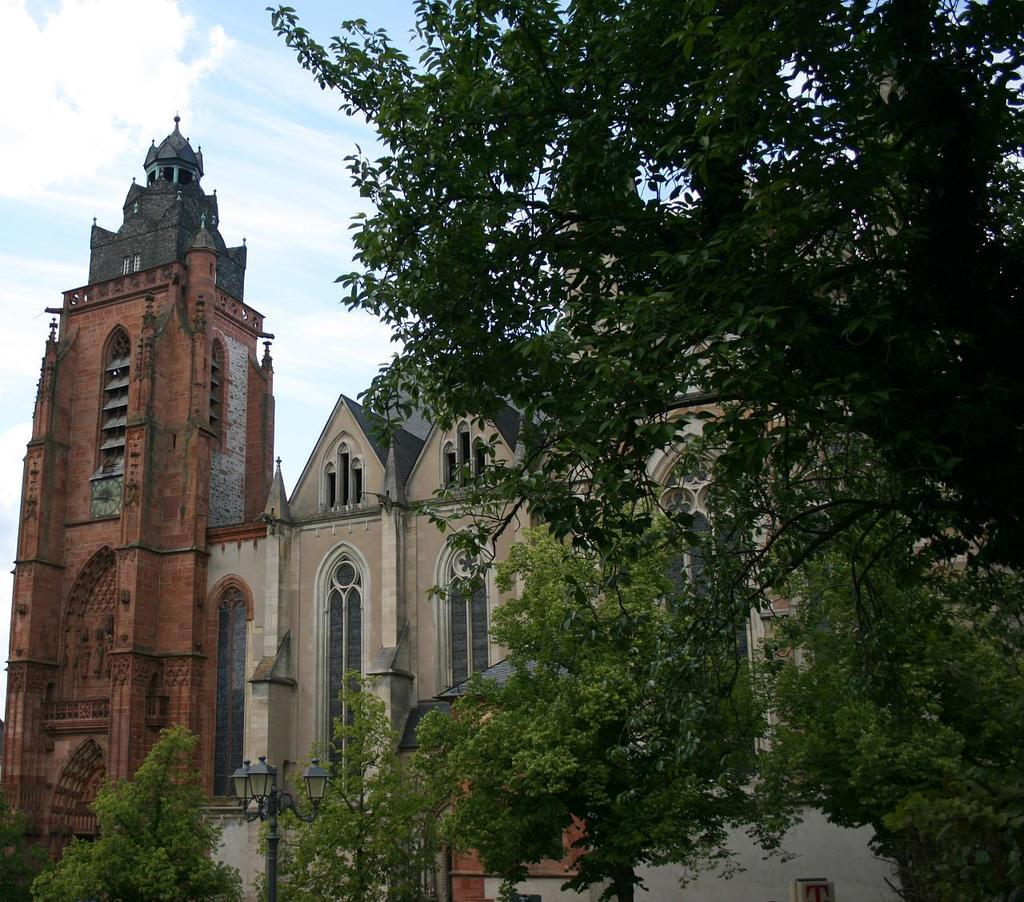What type of structure is visible in the image? There is a building with windows in the image. What natural elements can be seen in the image? There are trees with branches and leaves in the image. What man-made object is located at the bottom of the image? There is a light pole at the bottom of the image. What is visible in the background of the image? The sky is visible in the image. Can you see a frog sitting on the light pole in the image? There is no frog present on the light pole in the image. What type of nose can be seen on the trees in the image? Trees do not have noses, so this question cannot be answered. 